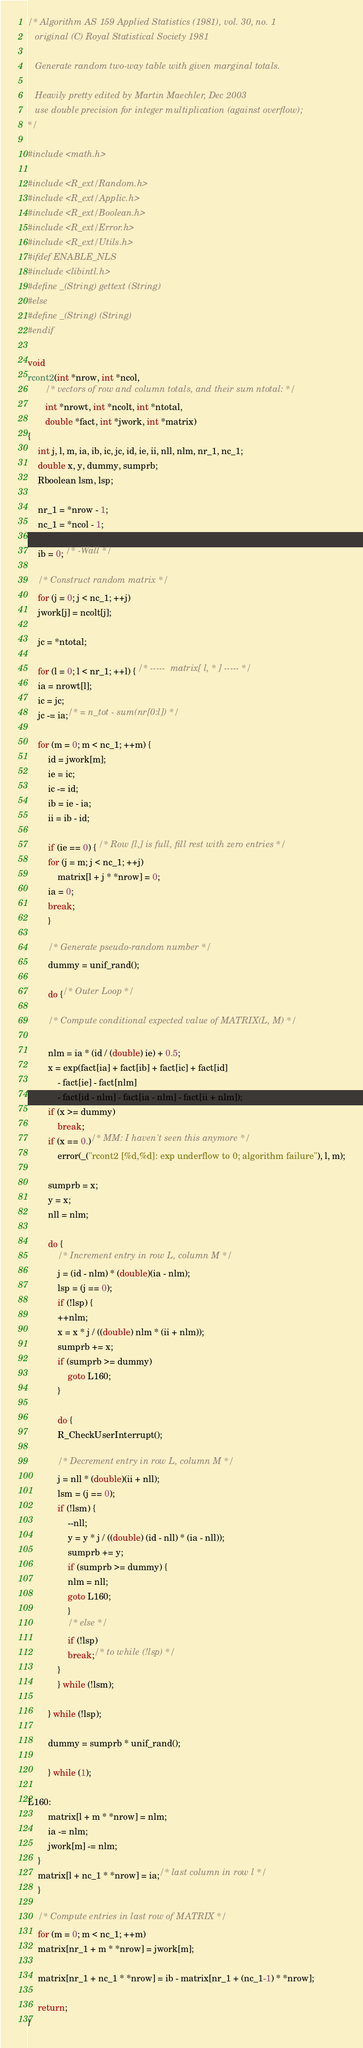<code> <loc_0><loc_0><loc_500><loc_500><_C_>/* Algorithm AS 159 Applied Statistics (1981), vol. 30, no. 1
   original (C) Royal Statistical Society 1981

   Generate random two-way table with given marginal totals.

   Heavily pretty edited by Martin Maechler, Dec 2003
   use double precision for integer multiplication (against overflow);
*/

#include <math.h>

#include <R_ext/Random.h>
#include <R_ext/Applic.h>
#include <R_ext/Boolean.h>
#include <R_ext/Error.h>
#include <R_ext/Utils.h>
#ifdef ENABLE_NLS
#include <libintl.h>
#define _(String) gettext (String)
#else
#define _(String) (String)
#endif

void
rcont2(int *nrow, int *ncol,
       /* vectors of row and column totals, and their sum ntotal: */
       int *nrowt, int *ncolt, int *ntotal,
       double *fact, int *jwork, int *matrix)
{
    int j, l, m, ia, ib, ic, jc, id, ie, ii, nll, nlm, nr_1, nc_1;
    double x, y, dummy, sumprb;
    Rboolean lsm, lsp;

    nr_1 = *nrow - 1;
    nc_1 = *ncol - 1;

    ib = 0; /* -Wall */

    /* Construct random matrix */
    for (j = 0; j < nc_1; ++j)
	jwork[j] = ncolt[j];

    jc = *ntotal;

    for (l = 0; l < nr_1; ++l) { /* -----  matrix[ l, * ] ----- */
	ia = nrowt[l];
	ic = jc;
	jc -= ia;/* = n_tot - sum(nr[0:l]) */

	for (m = 0; m < nc_1; ++m) {
	    id = jwork[m];
	    ie = ic;
	    ic -= id;
	    ib = ie - ia;
	    ii = ib - id;

	    if (ie == 0) { /* Row [l,] is full, fill rest with zero entries */
		for (j = m; j < nc_1; ++j)
		    matrix[l + j * *nrow] = 0;
		ia = 0;
		break;
	    }

	    /* Generate pseudo-random number */
	    dummy = unif_rand();

	    do {/* Outer Loop */

		/* Compute conditional expected value of MATRIX(L, M) */

		nlm = ia * (id / (double) ie) + 0.5;
		x = exp(fact[ia] + fact[ib] + fact[ic] + fact[id]
			- fact[ie] - fact[nlm]
			- fact[id - nlm] - fact[ia - nlm] - fact[ii + nlm]);
		if (x >= dummy)
		    break;
		if (x == 0.)/* MM: I haven't seen this anymore */
		    error(_("rcont2 [%d,%d]: exp underflow to 0; algorithm failure"), l, m);

		sumprb = x;
		y = x;
		nll = nlm;

		do {
		    /* Increment entry in row L, column M */
		    j = (id - nlm) * (double)(ia - nlm);
		    lsp = (j == 0);
		    if (!lsp) {
			++nlm;
			x = x * j / ((double) nlm * (ii + nlm));
			sumprb += x;
			if (sumprb >= dummy)
			    goto L160;
		    }

		    do {
			R_CheckUserInterrupt();

			/* Decrement entry in row L, column M */
			j = nll * (double)(ii + nll);
			lsm = (j == 0);
			if (!lsm) {
			    --nll;
			    y = y * j / ((double) (id - nll) * (ia - nll));
			    sumprb += y;
			    if (sumprb >= dummy) {
				nlm = nll;
				goto L160;
			    }
			    /* else */
			    if (!lsp)
				break;/* to while (!lsp) */
			}
		    } while (!lsm);

		} while (!lsp);

		dummy = sumprb * unif_rand();

	    } while (1);

L160:
	    matrix[l + m * *nrow] = nlm;
	    ia -= nlm;
	    jwork[m] -= nlm;
	}
	matrix[l + nc_1 * *nrow] = ia;/* last column in row l */
    }

    /* Compute entries in last row of MATRIX */
    for (m = 0; m < nc_1; ++m)
	matrix[nr_1 + m * *nrow] = jwork[m];

    matrix[nr_1 + nc_1 * *nrow] = ib - matrix[nr_1 + (nc_1-1) * *nrow];

    return;
}
</code> 